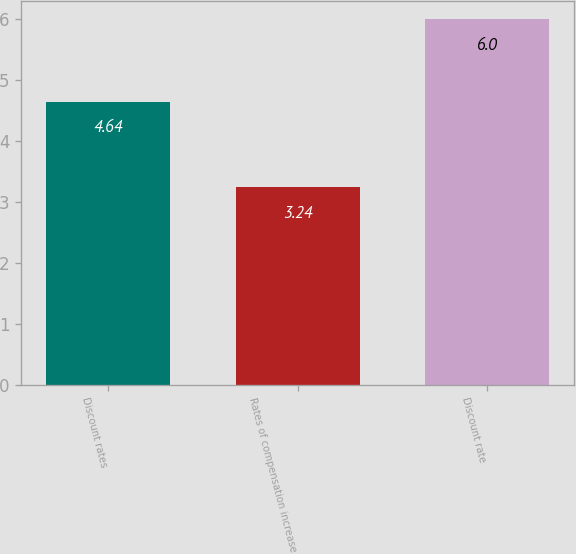Convert chart. <chart><loc_0><loc_0><loc_500><loc_500><bar_chart><fcel>Discount rates<fcel>Rates of compensation increase<fcel>Discount rate<nl><fcel>4.64<fcel>3.24<fcel>6<nl></chart> 